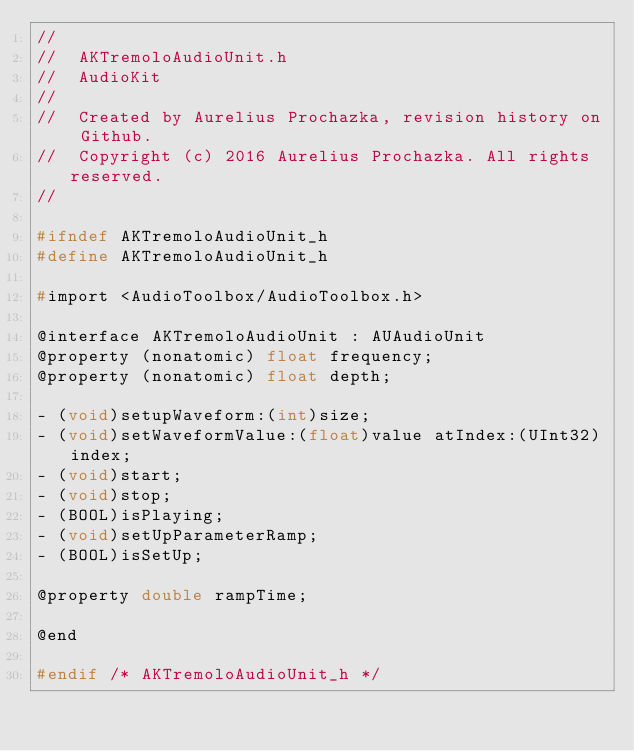<code> <loc_0><loc_0><loc_500><loc_500><_C_>//
//  AKTremoloAudioUnit.h
//  AudioKit
//
//  Created by Aurelius Prochazka, revision history on Github.
//  Copyright (c) 2016 Aurelius Prochazka. All rights reserved.
//

#ifndef AKTremoloAudioUnit_h
#define AKTremoloAudioUnit_h

#import <AudioToolbox/AudioToolbox.h>

@interface AKTremoloAudioUnit : AUAudioUnit
@property (nonatomic) float frequency;
@property (nonatomic) float depth;

- (void)setupWaveform:(int)size;
- (void)setWaveformValue:(float)value atIndex:(UInt32)index;
- (void)start;
- (void)stop;
- (BOOL)isPlaying;
- (void)setUpParameterRamp;
- (BOOL)isSetUp;

@property double rampTime;

@end

#endif /* AKTremoloAudioUnit_h */
</code> 